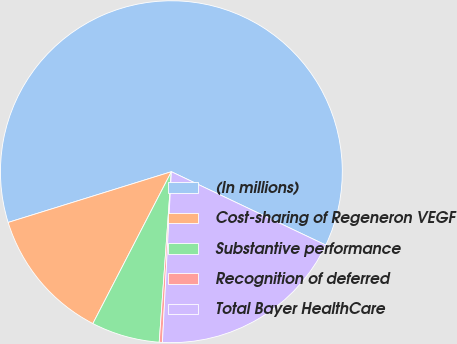<chart> <loc_0><loc_0><loc_500><loc_500><pie_chart><fcel>(In millions)<fcel>Cost-sharing of Regeneron VEGF<fcel>Substantive performance<fcel>Recognition of deferred<fcel>Total Bayer HealthCare<nl><fcel>61.85%<fcel>12.61%<fcel>6.46%<fcel>0.3%<fcel>18.77%<nl></chart> 